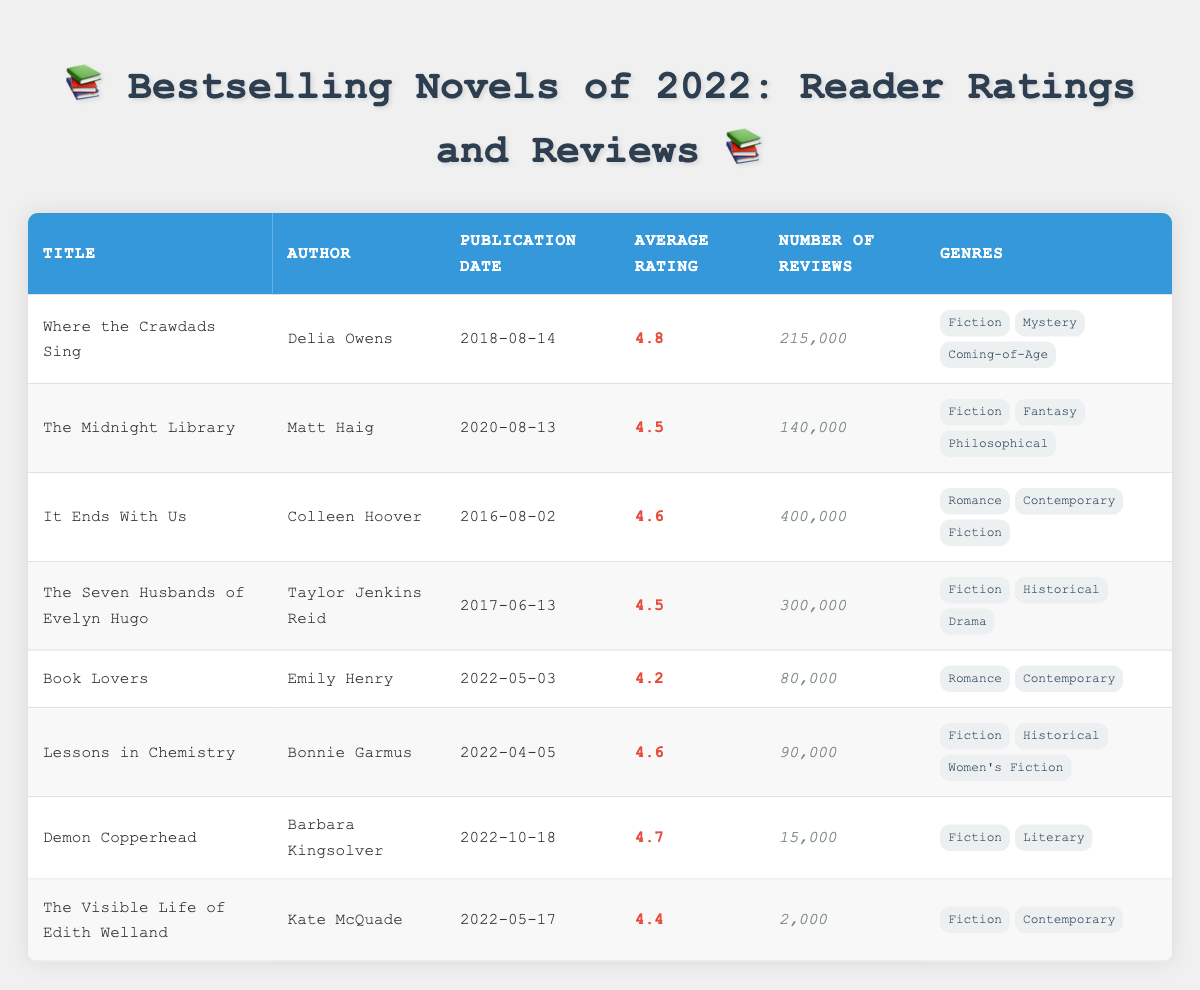What is the average rating of "Lessons in Chemistry"? The average rating of "Lessons in Chemistry" is listed directly in the table as 4.6.
Answer: 4.6 How many reviews did "Demon Copperhead" receive? The number of reviews for "Demon Copperhead" is given in the table as 15,000.
Answer: 15,000 Which novel has the highest average rating? To find the novel with the highest average rating, I compare all the average ratings from the table. "Where the Crawdads Sing" has the highest rating of 4.8.
Answer: Where the Crawdads Sing Is "Book Lovers" a historical fiction novel? By examining the genre listed for "Book Lovers," which includes "Romance" and "Contemporary," it is clear that it does not fall under the historical fiction category.
Answer: No What is the total number of reviews for "The Seven Husbands of Evelyn Hugo" and "It Ends With Us"? To find the total reviews, I add the number of reviews for both novels: 300,000 (The Seven Husbands of Evelyn Hugo) + 400,000 (It Ends With Us) = 700,000.
Answer: 700,000 Which books were published in 2022? I examine the publication dates and find that "Book Lovers", "Lessons in Chemistry", "Demon Copperhead", and "The Visible Life of Edith Welland" were all published in 2022.
Answer: Book Lovers, Lessons in Chemistry, Demon Copperhead, The Visible Life of Edith Welland What is the average rating of novels that are classified as "Fiction"? I first identify the novels classified as "Fiction": "Where the Crawdads Sing", "The Midnight Library", "It Ends With Us", "The Seven Husbands of Evelyn Hugo", "Lessons in Chemistry", "Demon Copperhead", and "The Visible Life of Edith Welland". Their ratings are 4.8, 4.5, 4.6, 4.5, 4.6, 4.7, and 4.4, respectively (total 7 novels). The average is (4.8 + 4.5 + 4.6 + 4.5 + 4.6 + 4.7 + 4.4) / 7 = 4.57.
Answer: 4.57 How many novels have an average rating less than 4.5? I count the novels with ratings below 4.5 from the table: "Book Lovers" (4.2), and "The Visible Life of Edith Welland" (4.4), resulting in a total of 2 novels.
Answer: 2 Which author has written the most reviewed novel in this table? By looking at the number of reviews, "It Ends With Us" by Colleen Hoover has the highest reviews with 400,000. Thus, Colleen Hoover is the author of the most reviewed novel.
Answer: Colleen Hoover 